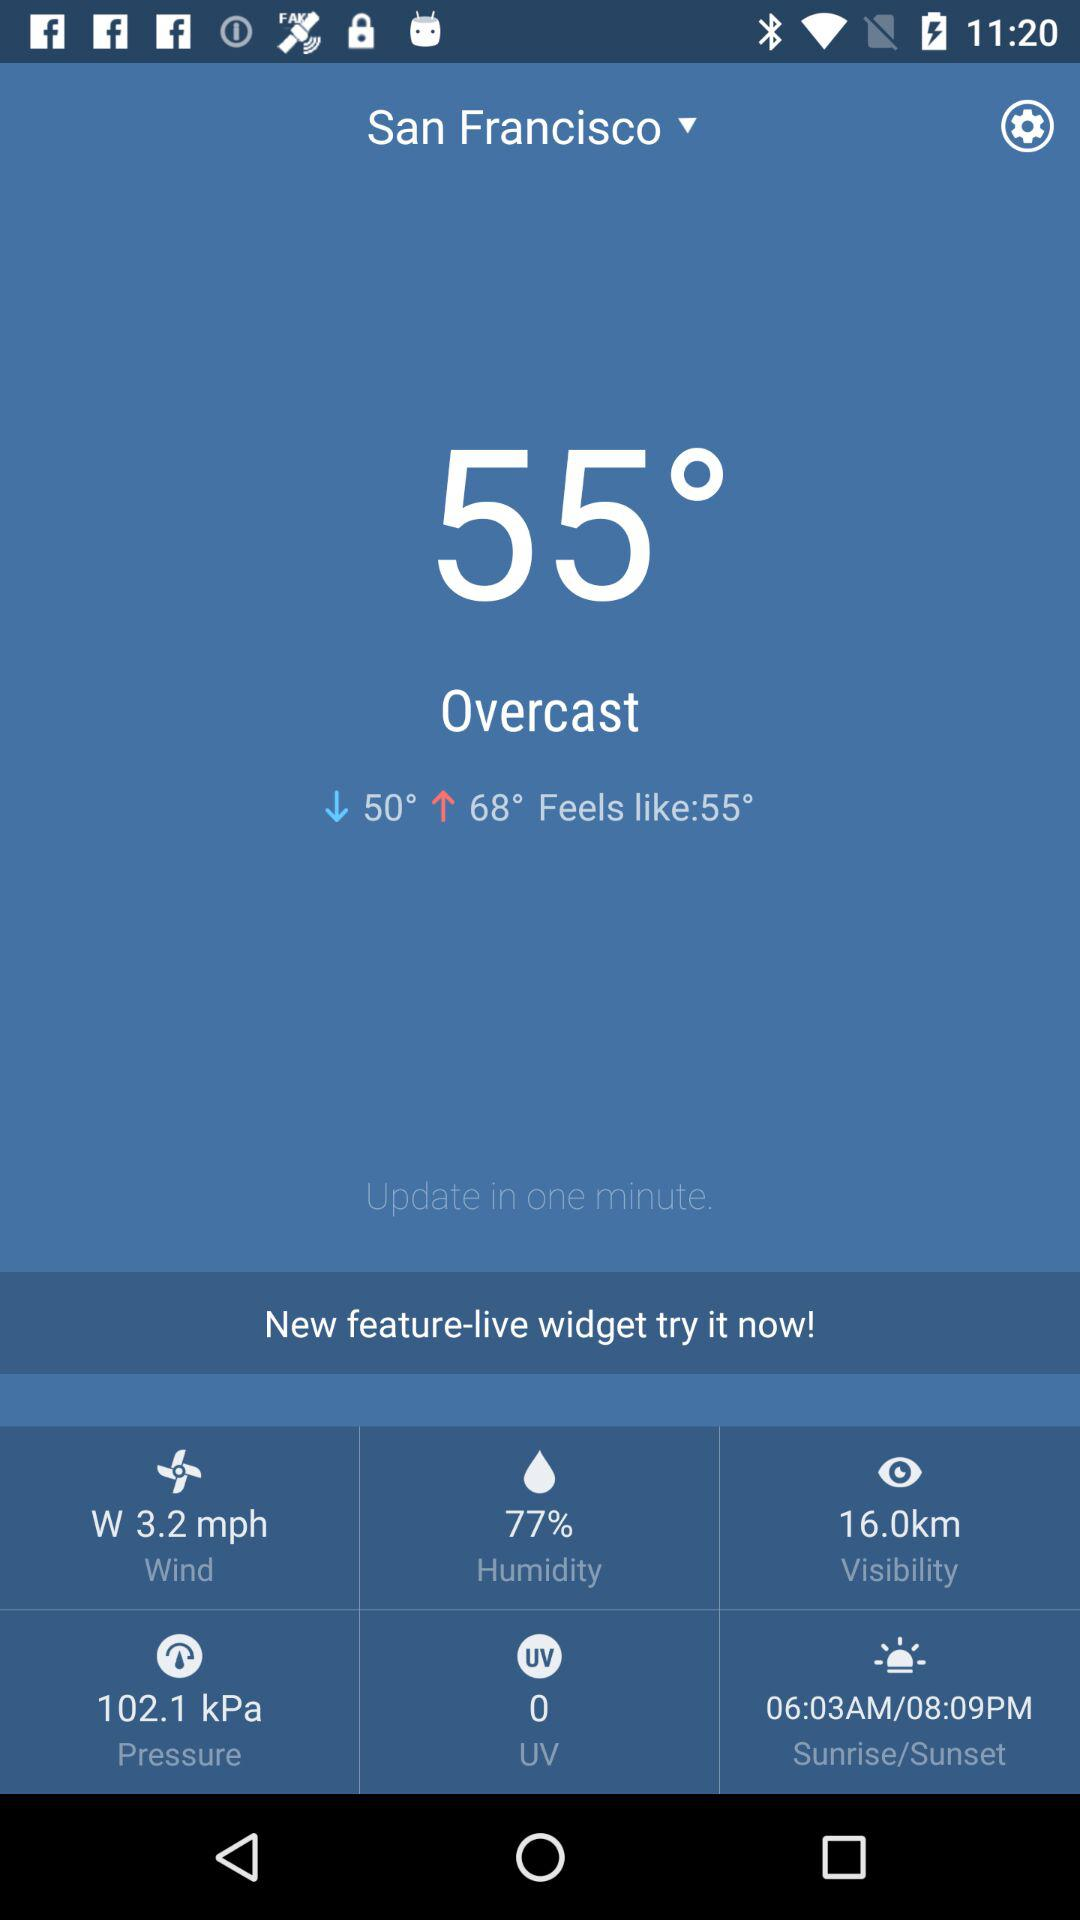What is the relative humidity?
Answer the question using a single word or phrase. 77% 